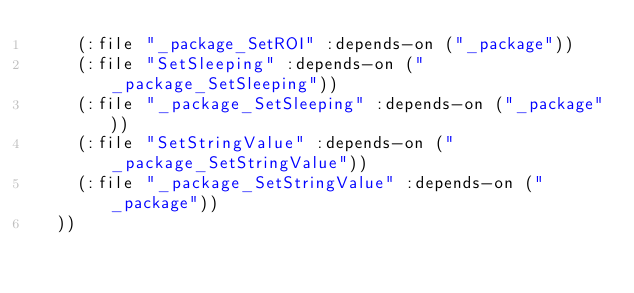Convert code to text. <code><loc_0><loc_0><loc_500><loc_500><_Lisp_>    (:file "_package_SetROI" :depends-on ("_package"))
    (:file "SetSleeping" :depends-on ("_package_SetSleeping"))
    (:file "_package_SetSleeping" :depends-on ("_package"))
    (:file "SetStringValue" :depends-on ("_package_SetStringValue"))
    (:file "_package_SetStringValue" :depends-on ("_package"))
  ))</code> 